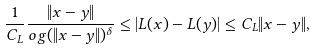<formula> <loc_0><loc_0><loc_500><loc_500>\frac { 1 } { C _ { L } } \frac { \| x - y \| } { \sl o g ( \| x - y \| ) ^ { \delta } } \leq | L ( x ) - L ( y ) | \leq C _ { L } \| x - y \| ,</formula> 